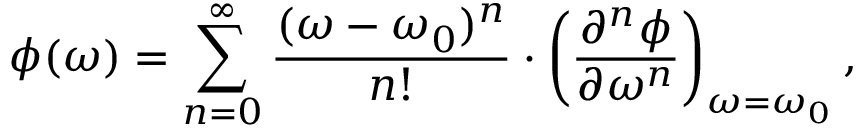Convert formula to latex. <formula><loc_0><loc_0><loc_500><loc_500>\phi ( \omega ) = \sum _ { n = 0 } ^ { \infty } \frac { ( \omega - \omega _ { 0 } ) ^ { n } } { n ! } \cdot \left ( \frac { \partial ^ { n } \phi } { \partial \omega ^ { n } } \right ) _ { \omega = \omega _ { 0 } } ,</formula> 